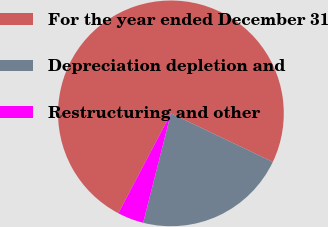Convert chart. <chart><loc_0><loc_0><loc_500><loc_500><pie_chart><fcel>For the year ended December 31<fcel>Depreciation depletion and<fcel>Restructuring and other<nl><fcel>74.36%<fcel>21.87%<fcel>3.76%<nl></chart> 